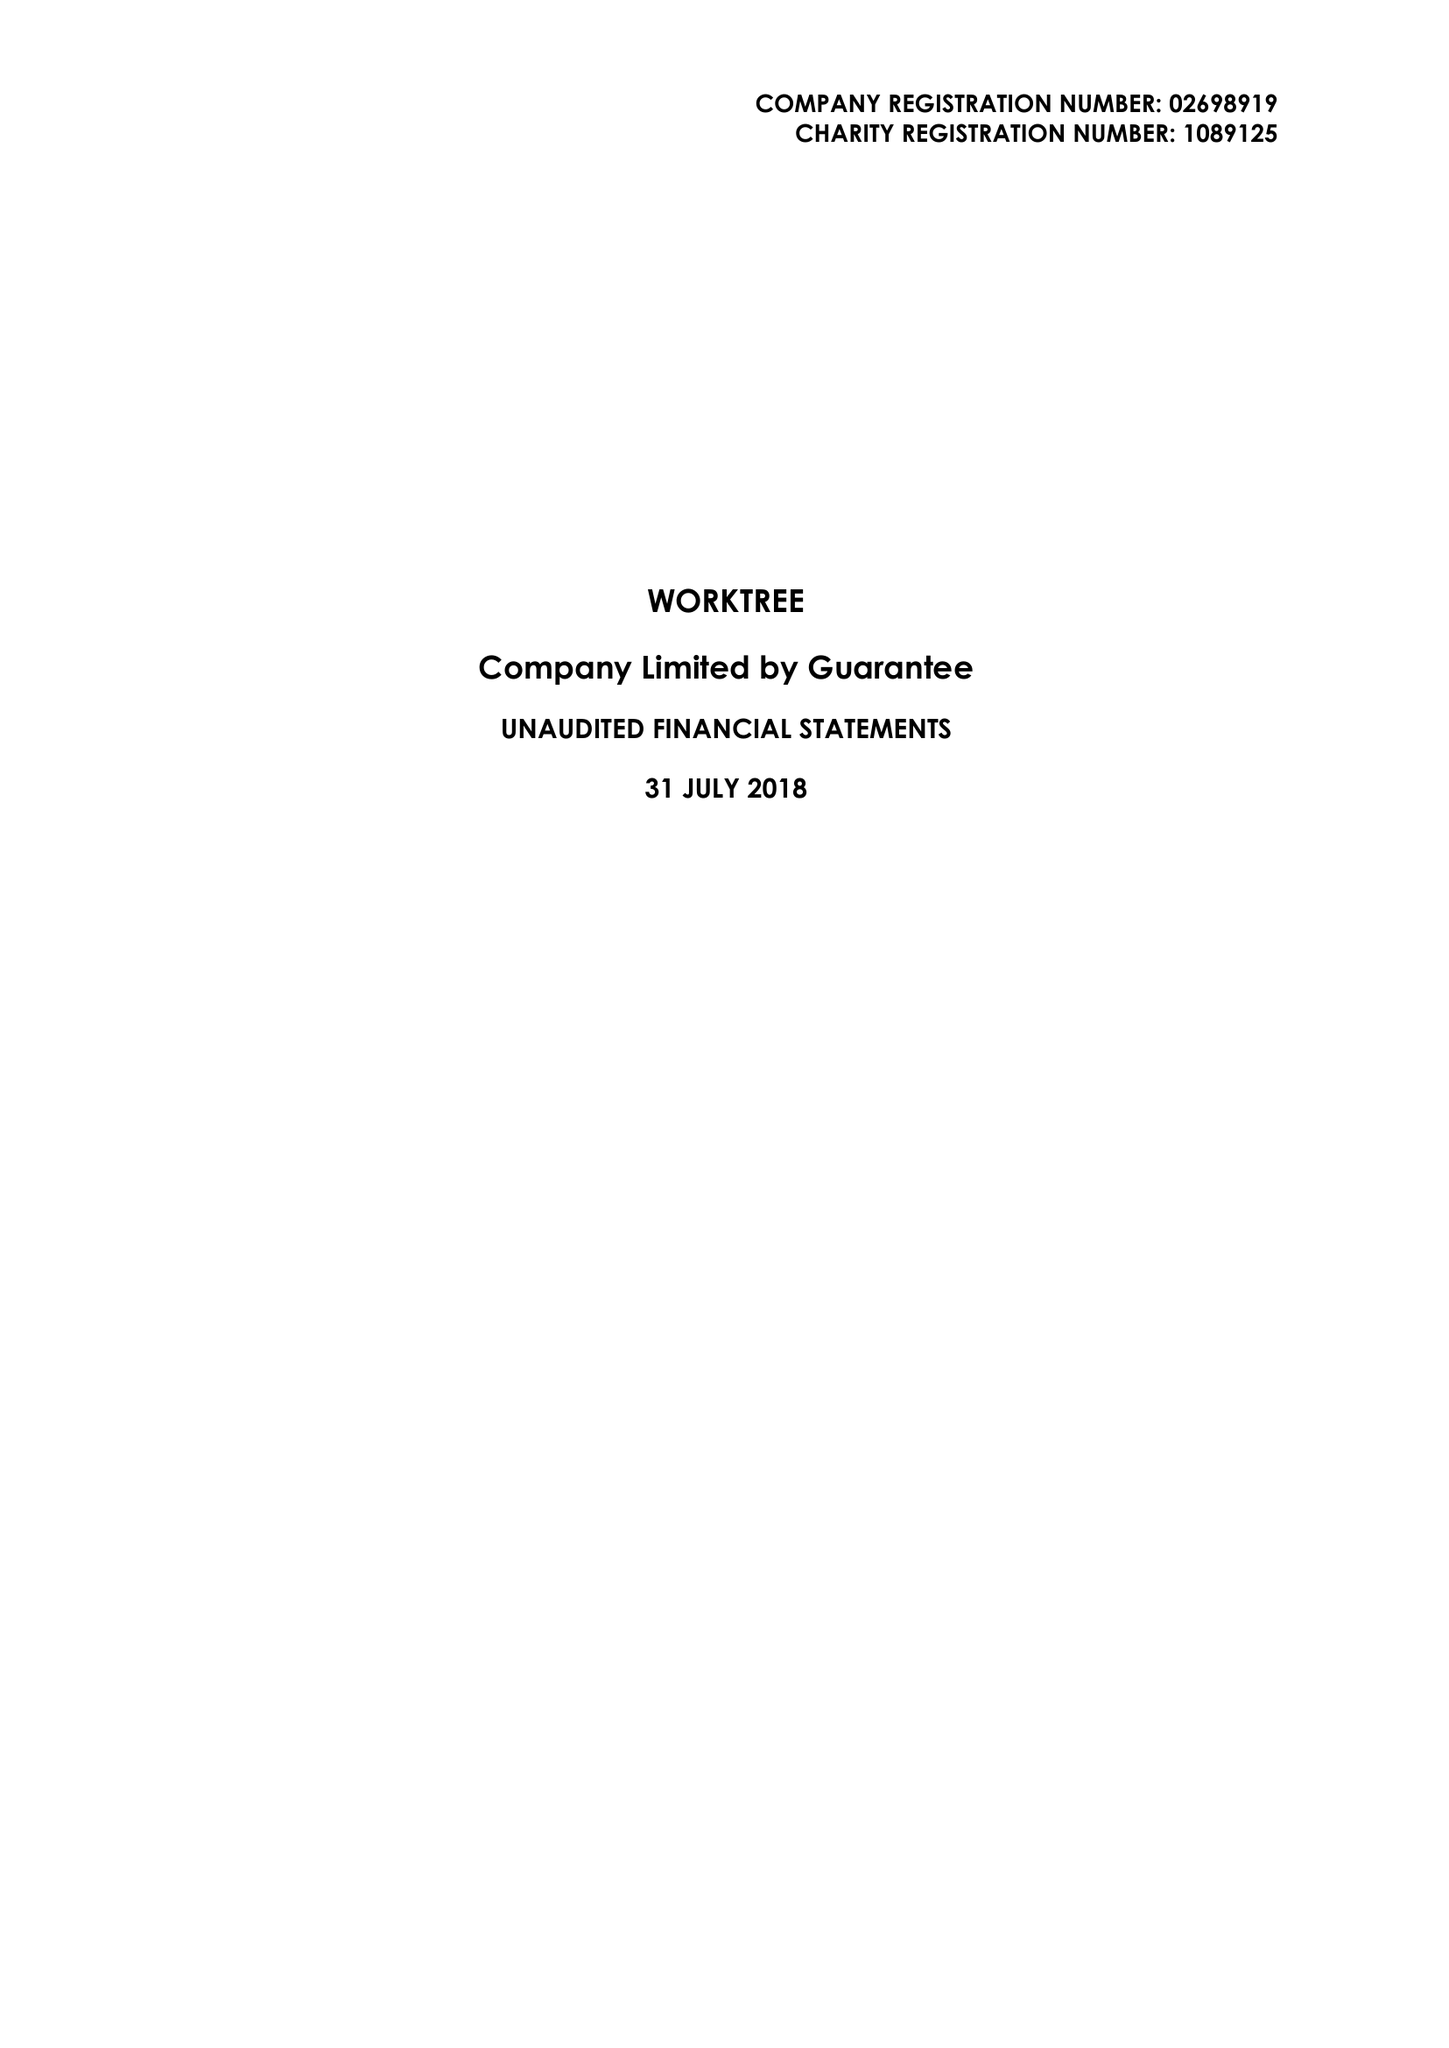What is the value for the spending_annually_in_british_pounds?
Answer the question using a single word or phrase. 80200.00 